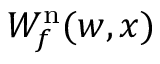Convert formula to latex. <formula><loc_0><loc_0><loc_500><loc_500>W _ { f } ^ { n } ( w , x )</formula> 